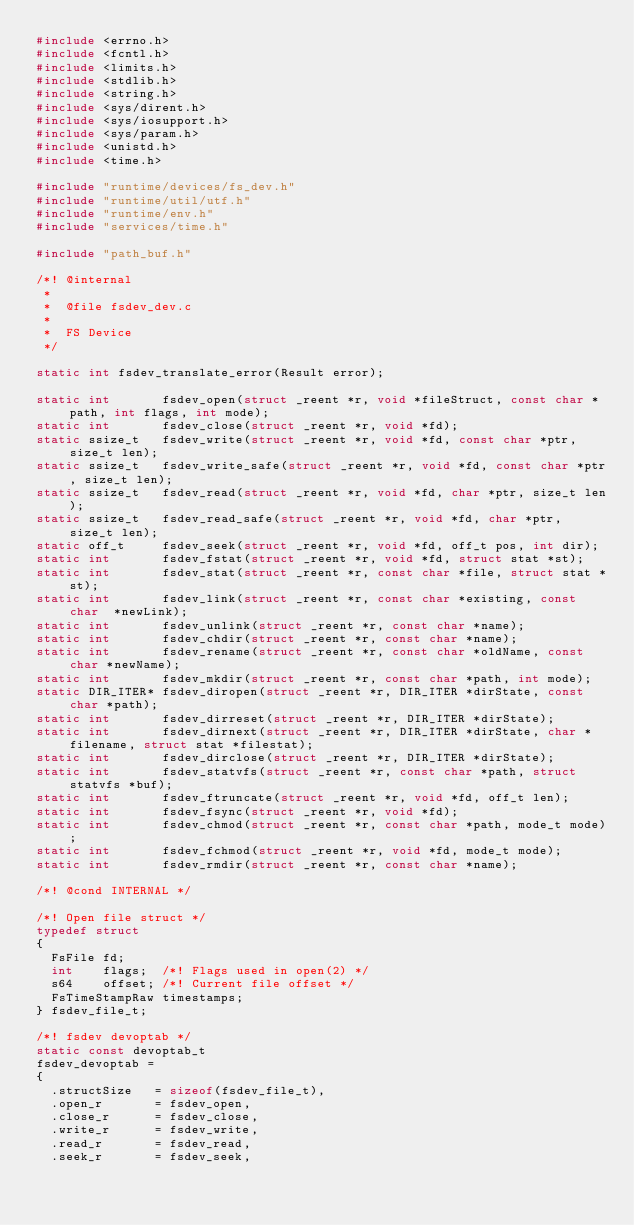Convert code to text. <code><loc_0><loc_0><loc_500><loc_500><_C_>#include <errno.h>
#include <fcntl.h>
#include <limits.h>
#include <stdlib.h>
#include <string.h>
#include <sys/dirent.h>
#include <sys/iosupport.h>
#include <sys/param.h>
#include <unistd.h>
#include <time.h>

#include "runtime/devices/fs_dev.h"
#include "runtime/util/utf.h"
#include "runtime/env.h"
#include "services/time.h"

#include "path_buf.h"

/*! @internal
 *
 *  @file fsdev_dev.c
 *
 *  FS Device
 */

static int fsdev_translate_error(Result error);

static int       fsdev_open(struct _reent *r, void *fileStruct, const char *path, int flags, int mode);
static int       fsdev_close(struct _reent *r, void *fd);
static ssize_t   fsdev_write(struct _reent *r, void *fd, const char *ptr, size_t len);
static ssize_t   fsdev_write_safe(struct _reent *r, void *fd, const char *ptr, size_t len);
static ssize_t   fsdev_read(struct _reent *r, void *fd, char *ptr, size_t len);
static ssize_t   fsdev_read_safe(struct _reent *r, void *fd, char *ptr, size_t len);
static off_t     fsdev_seek(struct _reent *r, void *fd, off_t pos, int dir);
static int       fsdev_fstat(struct _reent *r, void *fd, struct stat *st);
static int       fsdev_stat(struct _reent *r, const char *file, struct stat *st);
static int       fsdev_link(struct _reent *r, const char *existing, const char  *newLink);
static int       fsdev_unlink(struct _reent *r, const char *name);
static int       fsdev_chdir(struct _reent *r, const char *name);
static int       fsdev_rename(struct _reent *r, const char *oldName, const char *newName);
static int       fsdev_mkdir(struct _reent *r, const char *path, int mode);
static DIR_ITER* fsdev_diropen(struct _reent *r, DIR_ITER *dirState, const char *path);
static int       fsdev_dirreset(struct _reent *r, DIR_ITER *dirState);
static int       fsdev_dirnext(struct _reent *r, DIR_ITER *dirState, char *filename, struct stat *filestat);
static int       fsdev_dirclose(struct _reent *r, DIR_ITER *dirState);
static int       fsdev_statvfs(struct _reent *r, const char *path, struct statvfs *buf);
static int       fsdev_ftruncate(struct _reent *r, void *fd, off_t len);
static int       fsdev_fsync(struct _reent *r, void *fd);
static int       fsdev_chmod(struct _reent *r, const char *path, mode_t mode);
static int       fsdev_fchmod(struct _reent *r, void *fd, mode_t mode);
static int       fsdev_rmdir(struct _reent *r, const char *name);

/*! @cond INTERNAL */

/*! Open file struct */
typedef struct
{
  FsFile fd;
  int    flags;  /*! Flags used in open(2) */
  s64    offset; /*! Current file offset */
  FsTimeStampRaw timestamps;
} fsdev_file_t;

/*! fsdev devoptab */
static const devoptab_t
fsdev_devoptab =
{
  .structSize   = sizeof(fsdev_file_t),
  .open_r       = fsdev_open,
  .close_r      = fsdev_close,
  .write_r      = fsdev_write,
  .read_r       = fsdev_read,
  .seek_r       = fsdev_seek,</code> 